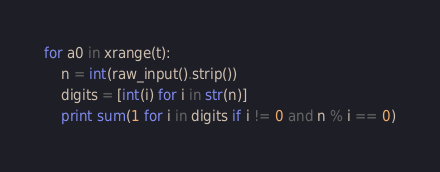<code> <loc_0><loc_0><loc_500><loc_500><_Python_>for a0 in xrange(t):
    n = int(raw_input().strip())
    digits = [int(i) for i in str(n)]
    print sum(1 for i in digits if i != 0 and n % i == 0)</code> 